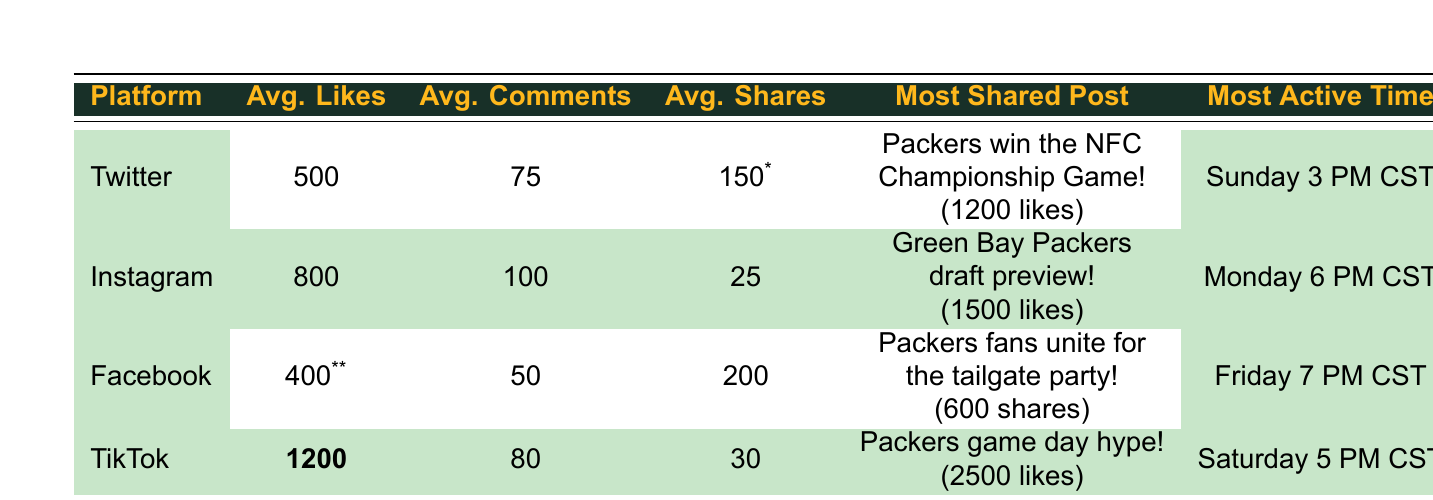What is the average number of likes on Instagram? The table shows the average likes on Instagram is listed directly under the "Avg. Likes" column, which states 800.
Answer: 800 Which post had the highest engagement on TikTok? The "Most Shared Post" for TikTok is "Packers game day hype!" with 2500 likes, making it the highest engagement post on that platform.
Answer: Packers game day hype! How many average shares does Facebook content receive? The average shares for Facebook is indicated in the "Avg. Shares" column, which shows a value of 200.
Answer: 200 Which platform has the highest average likes? By comparing the "Avg. Likes" column, TikTok has 1200 average likes, which is the highest among the platforms.
Answer: TikTok What time is TikTok most active for engagement? The "Most Active Time" listed for TikTok is "Saturday 5 PM CST," as found in the corresponding cell.
Answer: Saturday 5 PM CST How many more average likes does Instagram have compared to Twitter? The average likes for Instagram is 800 and for Twitter is 500, so calculating the difference: 800 - 500 = 300.
Answer: 300 Does Facebook have more average comments than Twitter? According to the table, Facebook has 50 average comments while Twitter has 75. Therefore, it does not have more.
Answer: No Calculate the total average engagement (likes, comments, shares) for the average TikTok post. For TikTok, the average engagement is calculated as follows: 1200 (likes) + 80 (comments) + 30 (shares) = 1310.
Answer: 1310 Which platform had the most shared post in terms of shares? The "Most Shared Post" for Facebook had 600 shares, which is the highest compared to the most shared posts from other platforms.
Answer: Facebook What is the average engagement value across all platforms in terms of likes? The average likes can be found by adding all average likes: (500 + 800 + 400 + 1200) = 2900. Then divide by the number of platforms, which is 4: 2900/4 = 725.
Answer: 725 